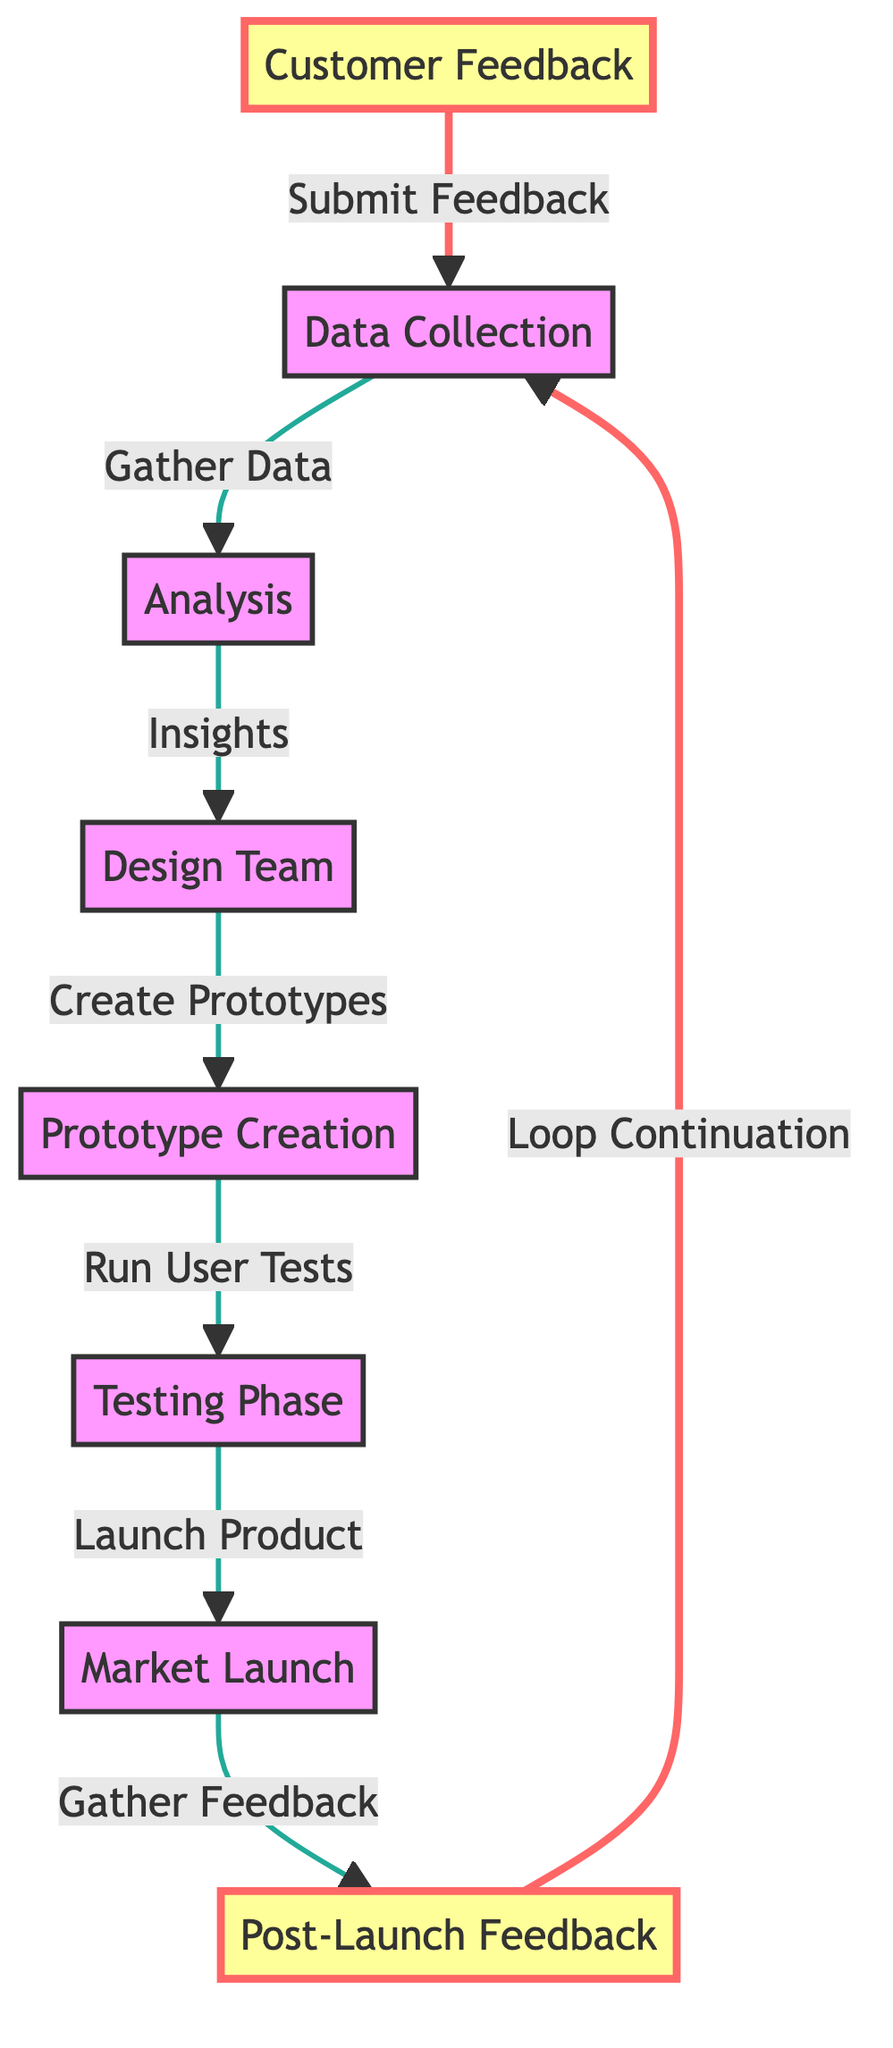What is the first step in the customer feedback loop? The first step is labeled as "Customer Feedback" in the diagram. This node is the starting point where consumers submit their feedback on products.
Answer: Customer Feedback How many main nodes are there in the diagram? The diagram contains eight main nodes, which represent various stages in the customer feedback loop process. By counting each labeled node, we can verify this number.
Answer: Eight What occurs after the "Analysis" step? After "Analysis," the flow indicates that the next step is the "Design Team." This connection illustrates that insights gained from analysis inform the design team for future products.
Answer: Design Team What happens during the "Testing Phase"? In the "Testing Phase," the prototypes created by the design team undergo user tests to evaluate their performance and gather further feedback. This node directly follows the prototype creation.
Answer: Run User Tests Which node directly gathers feedback after the product is launched? The node that follows the launch of the product is "Post-Launch Feedback," which is where the company collects consumer opinions about the new sneaker after it is available in the market.
Answer: Post-Launch Feedback How many edges are there connecting the nodes in the diagram? The diagram illustrates a total of seven edges connecting the various steps in the customer feedback loop. By tracing each line that connects nodes provides this count.
Answer: Seven What is the final feedback process that continues the loop? The final process that reinforces the loop in the diagram is "Loop Continuation," which indicates that the post-launch feedback leads back to the data collection phase.
Answer: Loop Continuation Which step comes directly after "Prototype Creation"? The step that comes directly after "Prototype Creation" is "Testing Phase." This sequence signifies that once prototypes are made, they are tested with users to assess quality and usability.
Answer: Testing Phase 